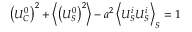<formula> <loc_0><loc_0><loc_500><loc_500>\left ( U _ { C } ^ { 0 } \right ) ^ { 2 } + \left \langle \left ( U _ { S } ^ { 0 } \right ) ^ { 2 } \right \rangle - a ^ { 2 } \left \langle U _ { S } ^ { i } U _ { S } ^ { i } \right \rangle _ { S } = 1</formula> 